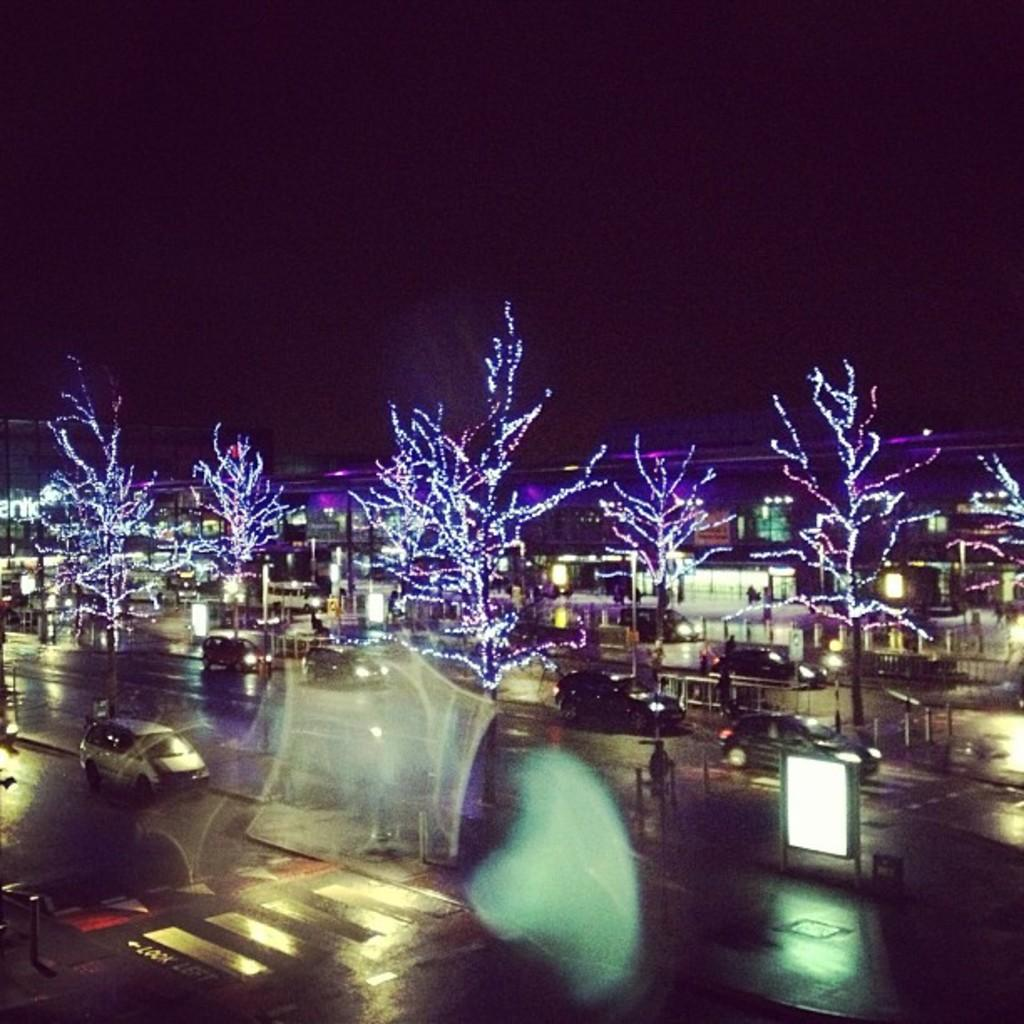What can be seen moving on the road in the image? There are vehicles on the road in the image. Who or what else can be seen in the image besides the vehicles? There are people, trees, buildings, lights, poles, and boards in the image. What is the general lighting condition in the image? The background of the image is dark. Can you tell me what type of notebook the people are using in the image? There is no notebook present in the image. What kind of air is visible in the image? There is no specific type of air visible in the image; it is a general atmospheric condition. How many trucks are present in the image? The provided facts do not mention trucks; only vehicles are mentioned, and their specific types are not specified. 